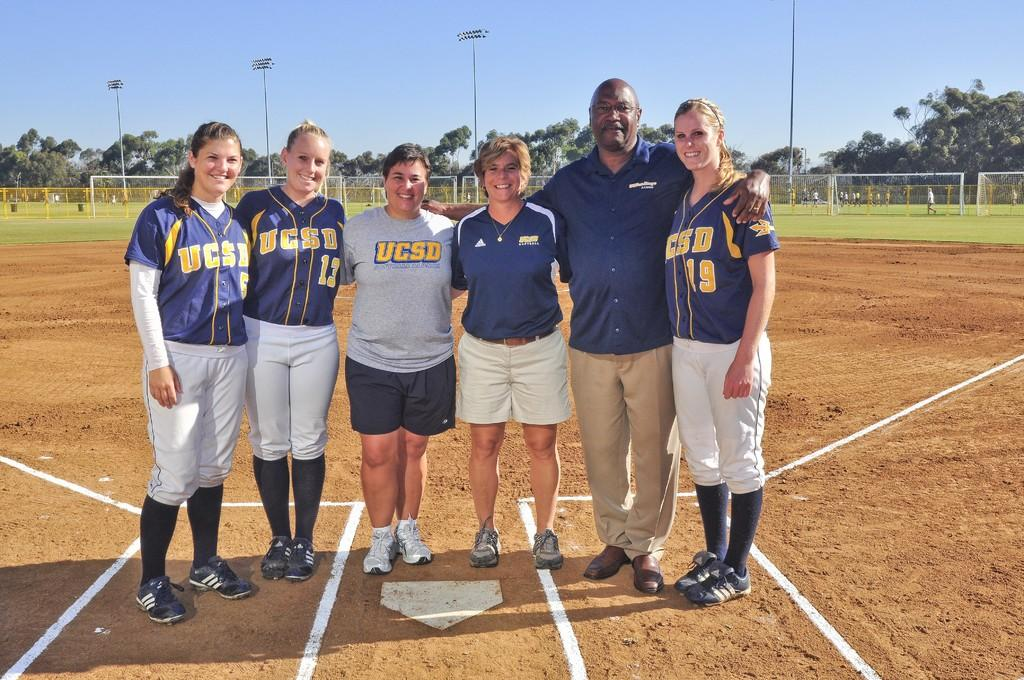Provide a one-sentence caption for the provided image. A picture of baseball player with the coach and one of them have the number 19 on her Jersey. 